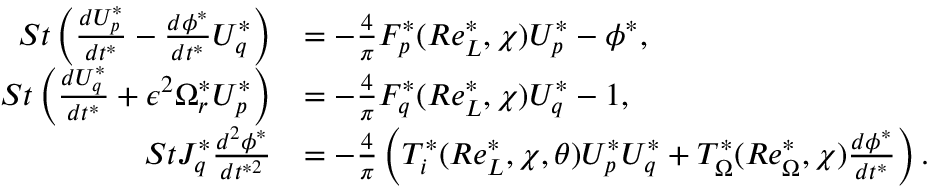<formula> <loc_0><loc_0><loc_500><loc_500>\begin{array} { r l } { S t \left ( \frac { d U _ { p } ^ { * } } { d t ^ { * } } - \frac { d \phi ^ { * } } { d t ^ { * } } U _ { q } ^ { * } \right ) } & { = - \frac { 4 } { \pi } F _ { p } ^ { * } ( R e _ { L } ^ { * } , \chi ) U _ { p } ^ { * } - \phi ^ { * } , } \\ { S t \left ( \frac { d U _ { q } ^ { * } } { d t ^ { * } } + \epsilon ^ { 2 } \Omega _ { r } ^ { * } U _ { p } ^ { * } \right ) } & { = - \frac { 4 } { \pi } F _ { q } ^ { * } ( R e _ { L } ^ { * } , \chi ) U _ { q } ^ { * } - 1 , } \\ { S t J _ { q } ^ { * } \frac { d ^ { 2 } \phi ^ { * } } { d t ^ { * 2 } } } & { = - \frac { 4 } { \pi } \left ( T _ { i } ^ { * } ( R e _ { L } ^ { * } , \chi , \theta ) U _ { p } ^ { * } U _ { q } ^ { * } + T _ { \Omega } ^ { * } ( R e _ { \Omega } ^ { * } , \chi ) \frac { d \phi ^ { * } } { d t ^ { * } } \right ) . } \end{array}</formula> 